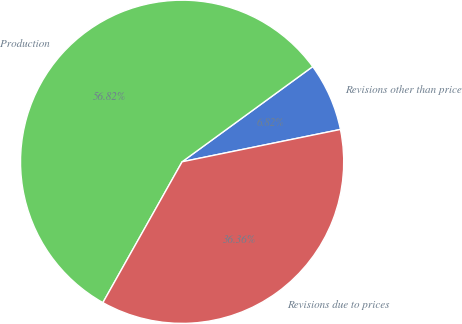<chart> <loc_0><loc_0><loc_500><loc_500><pie_chart><fcel>Revisions other than price<fcel>Production<fcel>Revisions due to prices<nl><fcel>6.82%<fcel>56.82%<fcel>36.36%<nl></chart> 